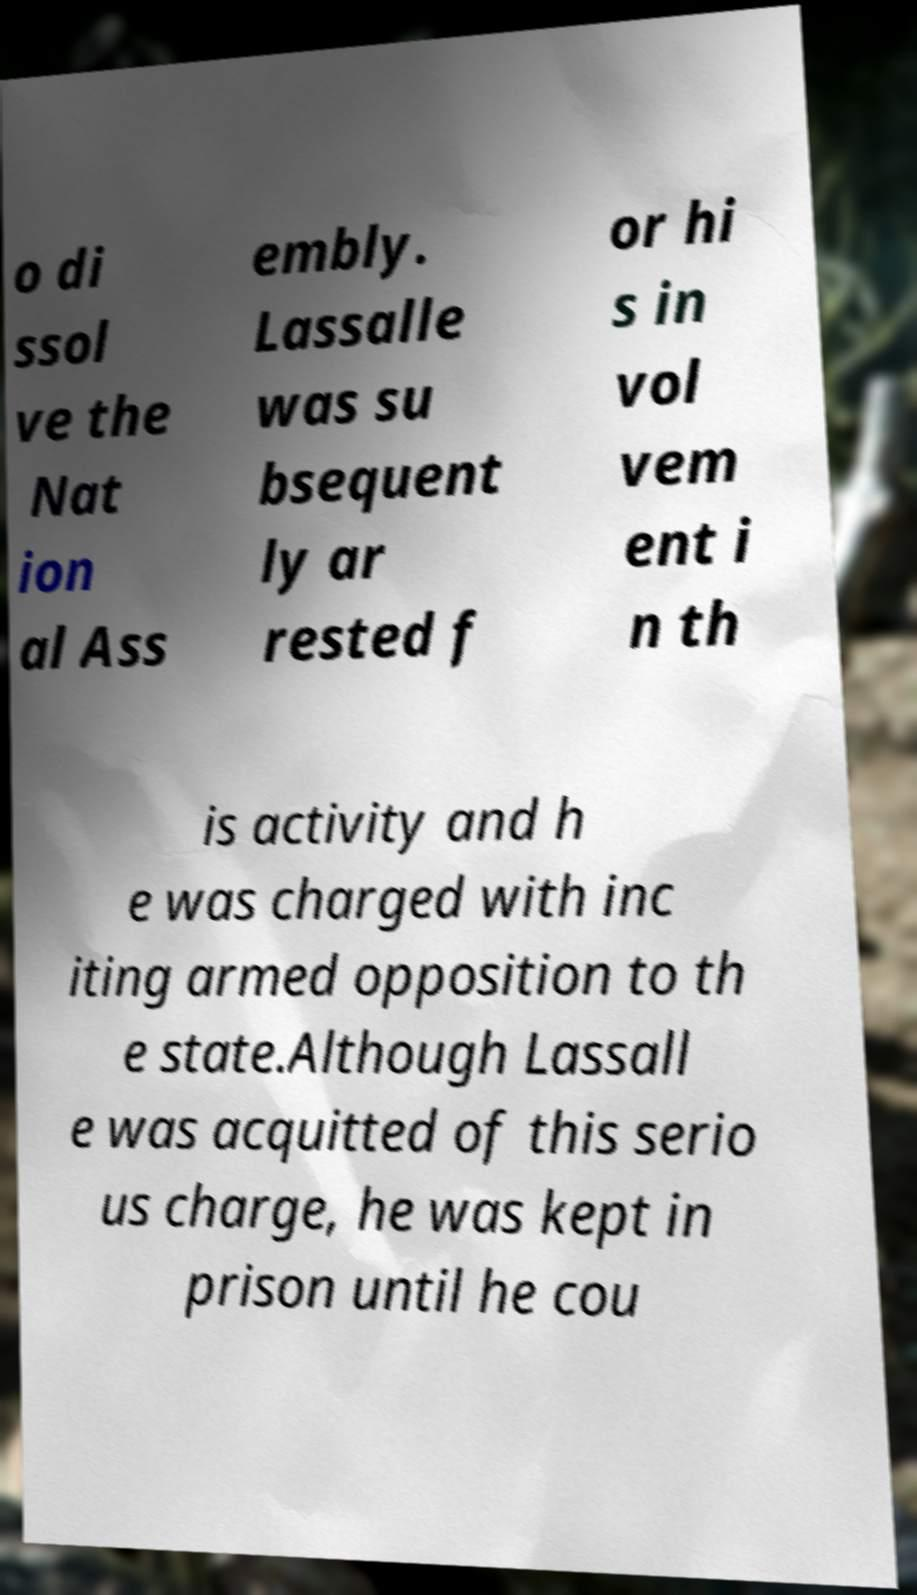Can you read and provide the text displayed in the image?This photo seems to have some interesting text. Can you extract and type it out for me? o di ssol ve the Nat ion al Ass embly. Lassalle was su bsequent ly ar rested f or hi s in vol vem ent i n th is activity and h e was charged with inc iting armed opposition to th e state.Although Lassall e was acquitted of this serio us charge, he was kept in prison until he cou 